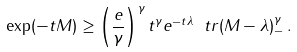<formula> <loc_0><loc_0><loc_500><loc_500>\exp ( - t M ) \geq \left ( \frac { e } { \gamma } \right ) ^ { \gamma } t ^ { \gamma } e ^ { - t \lambda } \ t r ( M - \lambda ) _ { - } ^ { \gamma } \, .</formula> 